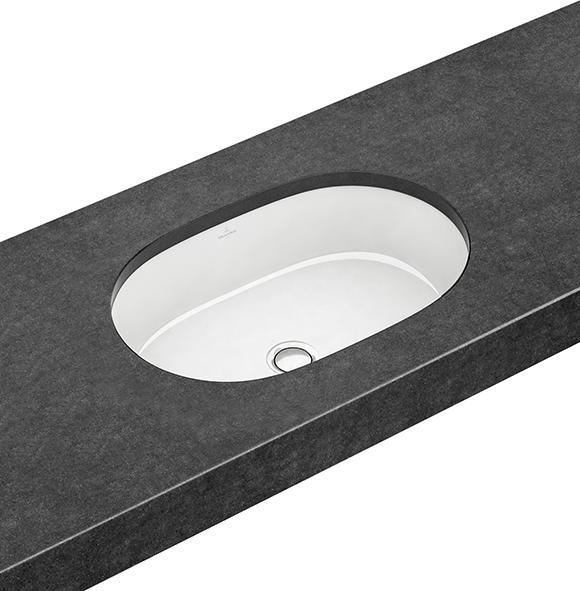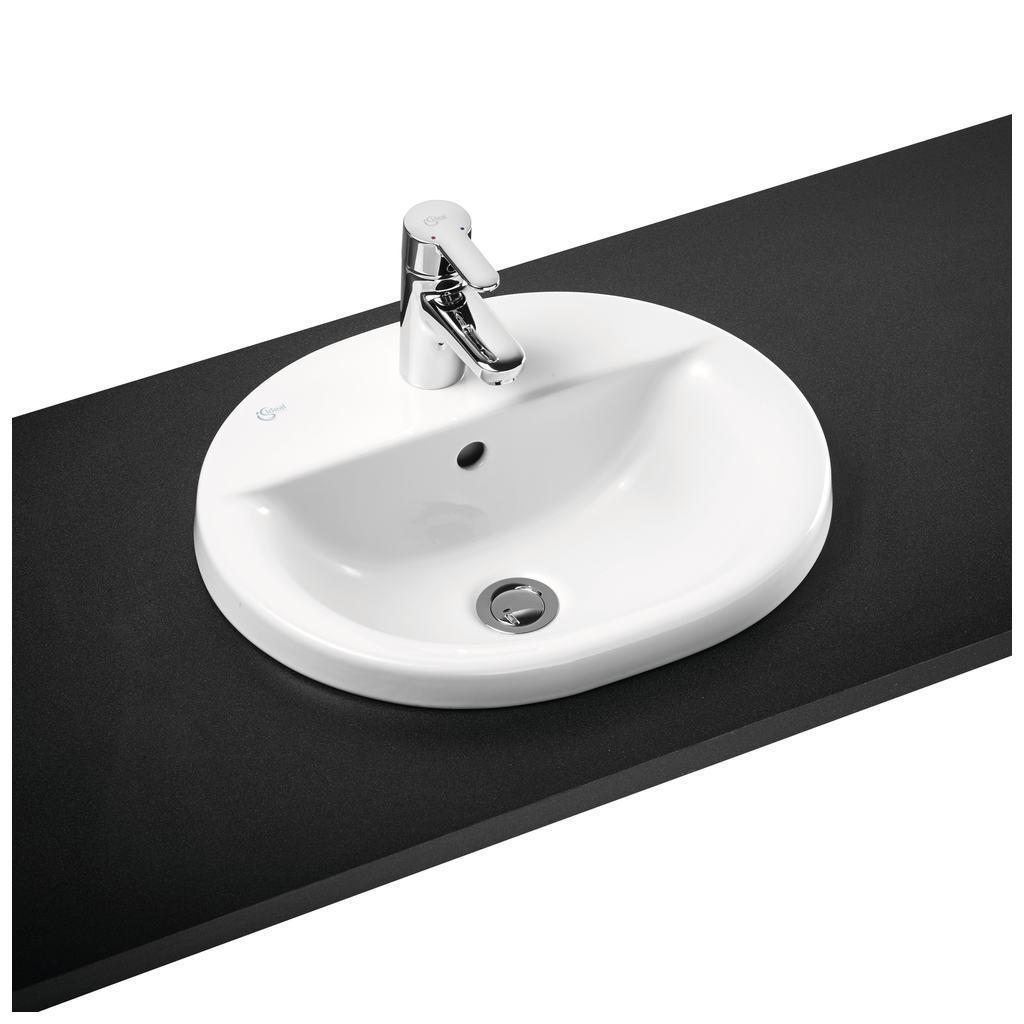The first image is the image on the left, the second image is the image on the right. Evaluate the accuracy of this statement regarding the images: "There are two oval shaped sinks installed in countertops.". Is it true? Answer yes or no. Yes. The first image is the image on the left, the second image is the image on the right. For the images shown, is this caption "An image shows a sink with a semi-circle interior and chrome fixture mounted to the basin's top." true? Answer yes or no. Yes. 